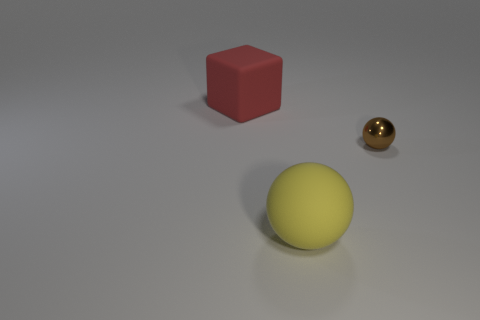Add 3 large red rubber objects. How many objects exist? 6 Subtract all cubes. How many objects are left? 2 Subtract all red objects. Subtract all yellow rubber spheres. How many objects are left? 1 Add 3 spheres. How many spheres are left? 5 Add 2 rubber spheres. How many rubber spheres exist? 3 Subtract 0 yellow blocks. How many objects are left? 3 